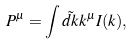Convert formula to latex. <formula><loc_0><loc_0><loc_500><loc_500>P ^ { \mu } = \int \tilde { d k } k ^ { \mu } I ( k ) ,</formula> 